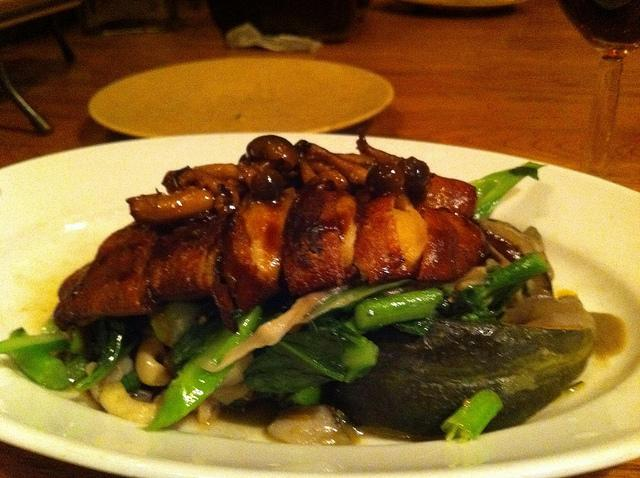What has caused the food on the plate to look shiny?

Choices:
A) air
B) sauce
C) glare
D) soda sauce 